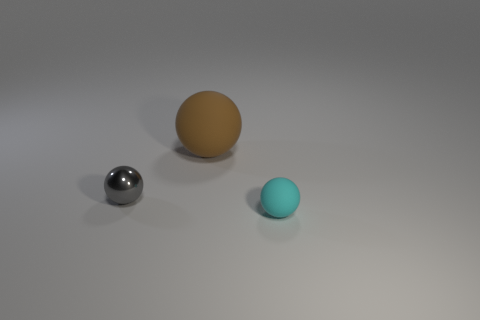Are there any other things that are the same size as the brown rubber thing?
Your answer should be compact. No. There is a matte sphere to the left of the cyan ball; how big is it?
Give a very brief answer. Large. What is the shape of the matte thing that is on the left side of the tiny sphere that is in front of the thing to the left of the large brown matte sphere?
Offer a very short reply. Sphere. There is a matte object to the right of the brown thing; what is its shape?
Give a very brief answer. Sphere. Is the brown object made of the same material as the tiny thing to the right of the tiny gray ball?
Keep it short and to the point. Yes. How many other objects are there of the same shape as the gray metallic object?
Your answer should be compact. 2. Are there any other things that are the same material as the small gray object?
Offer a terse response. No. What shape is the thing that is left of the ball that is behind the small shiny sphere?
Give a very brief answer. Sphere. There is a thing that is in front of the gray sphere; is its shape the same as the gray object?
Offer a terse response. Yes. Are there more small spheres in front of the tiny gray sphere than large objects behind the brown matte object?
Ensure brevity in your answer.  Yes. 